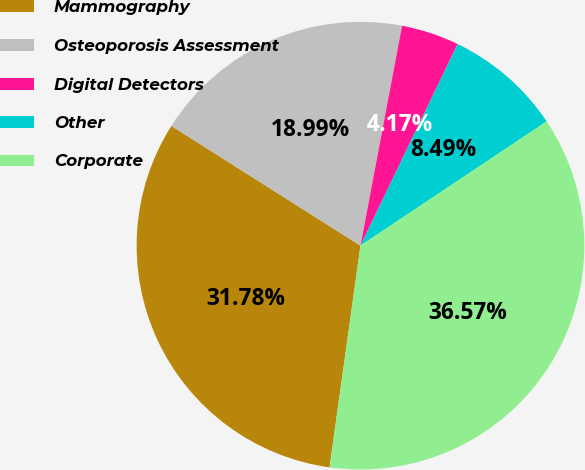Convert chart. <chart><loc_0><loc_0><loc_500><loc_500><pie_chart><fcel>Mammography<fcel>Osteoporosis Assessment<fcel>Digital Detectors<fcel>Other<fcel>Corporate<nl><fcel>31.78%<fcel>18.99%<fcel>4.17%<fcel>8.49%<fcel>36.57%<nl></chart> 